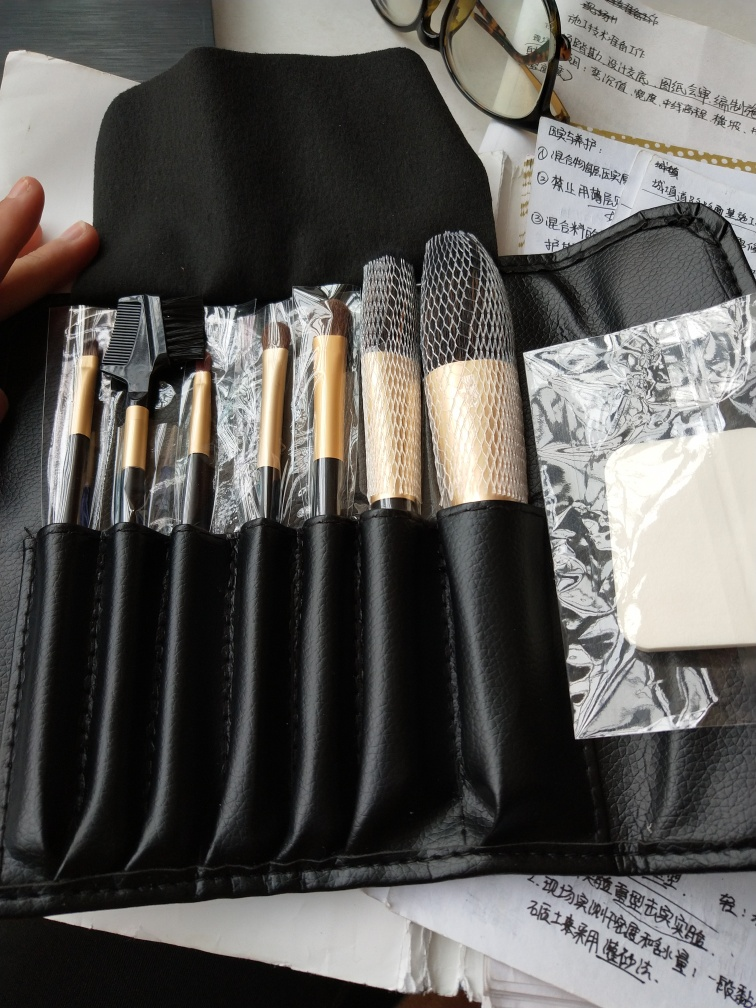What is the quality of this image?
A. Poor
B. Bad
C. Good
Answer with the option's letter from the given choices directly.
 C. 